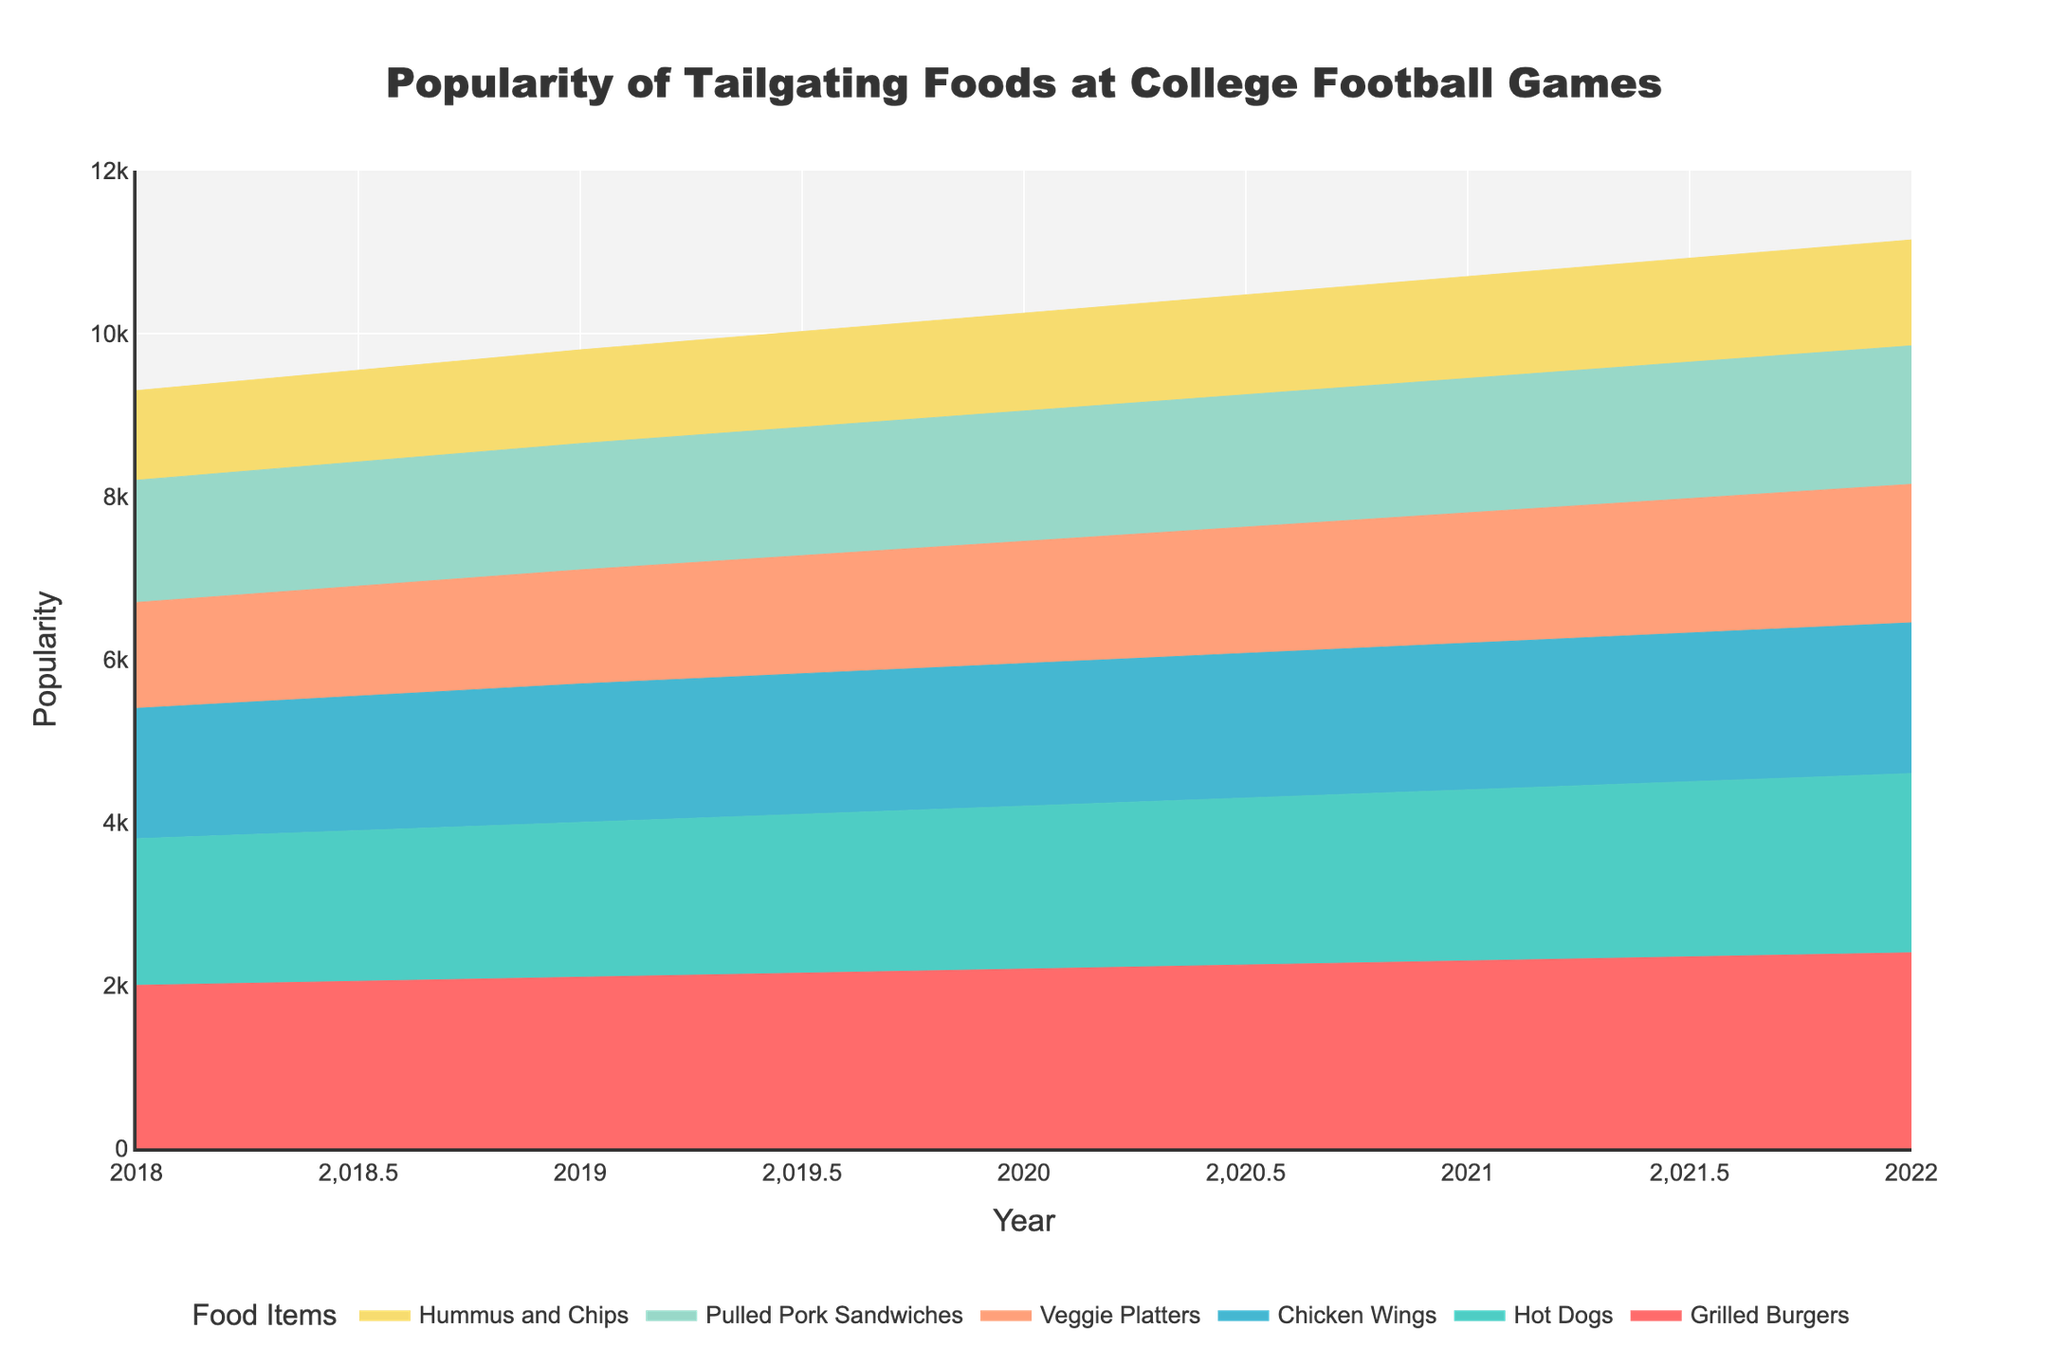What food item remained consistently popular from 2018 to 2022? By observing the plot, we can see the trend lines of each food item. The item that shows consistent popularity and continuous upward trend across all years is Grilled Burgers.
Answer: Grilled Burgers Which year saw the highest popularity for Chicken Wings? To find the highest popularity, we look at the peak of the Chicken Wings area. The highest point occurs in 2022.
Answer: 2022 What was the overall trend in the popularity of Veggie Platters over the years? By examining the area representing Veggie Platters from 2018 to 2022, we can see a steady increase year on year. This shows an overall upward trend.
Answer: Upward Which two food items had the closest popularity levels in 2022? Observing the heights of the areas at the year 2022, Pulled Pork Sandwiches and Veggie Platters have nearly the same height, indicating close popularity levels.
Answer: Pulled Pork Sandwiches and Veggie Platters What is the difference in popularity between Grilled Burgers and Hummus and Chips in 2018? The popularity for Grilled Burgers in 2018 is 2000 and for Hummus and Chips it is 1100. The difference is 2000 - 1100 = 900.
Answer: 900 What is the general trend observed for Hot Dogs from 2018 to 2022? Reviewing the trend line for Hot Dogs, there is a steady increase in popularity each year.
Answer: Increase How does the popularity of Pulled Pork Sandwiches change from 2018 to 2020? The popularity starts at 1500 in 2018, increases to 1550 in 2019, and then to 1600 in 2020. Thus, it shows a steady increase over these years.
Answer: Steady increase In which year did Hummus and Chips have the lowest popularity, and what was the value? The lowest popularity for Hummus and Chips occurs in 2018, with a value of 1100.
Answer: 2018, 1100 How much more popular were Hot Dogs compared to Chicken Wings in 2021? Hot Dogs had a popularity of 2100 and Chicken Wings had 1800 in 2021. The difference is 2100 - 1800 = 300.
Answer: 300 What does the shaded area represent in this plot and how is it useful for comparing different food items? The shaded area under each line represents the popularity of that food item over the years. It is useful because it allows for a visual comparison of how the popularity trends for different food items overlap or differ across the same timespan.
Answer: Popularity comparison 